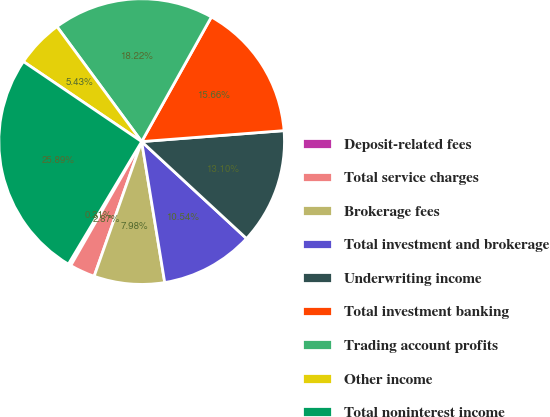Convert chart. <chart><loc_0><loc_0><loc_500><loc_500><pie_chart><fcel>Deposit-related fees<fcel>Total service charges<fcel>Brokerage fees<fcel>Total investment and brokerage<fcel>Underwriting income<fcel>Total investment banking<fcel>Trading account profits<fcel>Other income<fcel>Total noninterest income<nl><fcel>0.31%<fcel>2.87%<fcel>7.98%<fcel>10.54%<fcel>13.1%<fcel>15.66%<fcel>18.22%<fcel>5.43%<fcel>25.89%<nl></chart> 